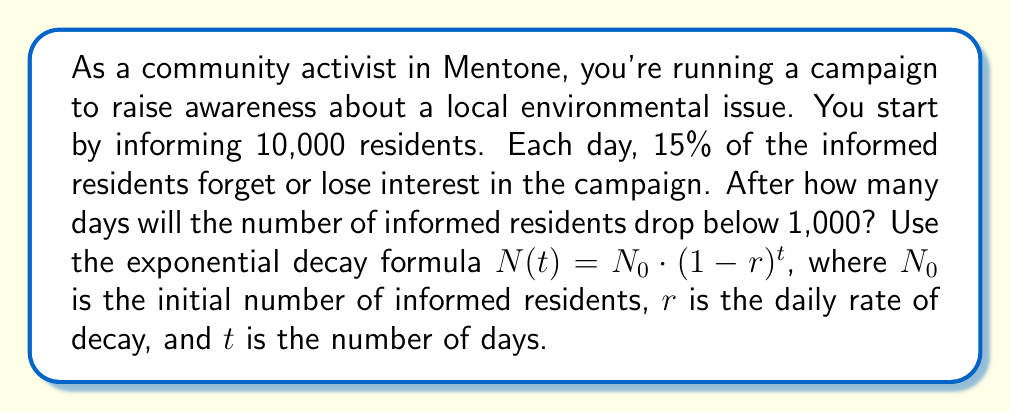Teach me how to tackle this problem. To solve this problem, we'll use the exponential decay formula:

$$N(t) = N_0 \cdot (1-r)^t$$

Where:
$N(t)$ is the number of informed residents after $t$ days
$N_0 = 10,000$ (initial number of informed residents)
$r = 0.15$ (15% daily decay rate)
$t$ is the number of days (what we're solving for)

We want to find $t$ when $N(t)$ becomes less than 1,000. Let's set up the equation:

$$1,000 = 10,000 \cdot (1-0.15)^t$$

Simplify:
$$1,000 = 10,000 \cdot (0.85)^t$$

Divide both sides by 10,000:
$$0.1 = (0.85)^t$$

Take the natural log of both sides:
$$\ln(0.1) = t \cdot \ln(0.85)$$

Solve for $t$:
$$t = \frac{\ln(0.1)}{\ln(0.85)}$$

Using a calculator:
$$t \approx 14.96$$

Since we can only have a whole number of days, we round up to 15 days.
Answer: It will take 15 days for the number of informed residents to drop below 1,000. 